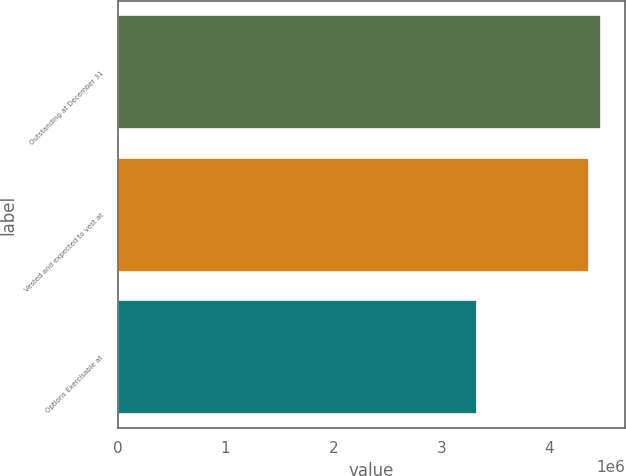Convert chart. <chart><loc_0><loc_0><loc_500><loc_500><bar_chart><fcel>Outstanding at December 31<fcel>Vested and expected to vest at<fcel>Options Exercisable at<nl><fcel>4.47941e+06<fcel>4.36747e+06<fcel>3.32934e+06<nl></chart> 